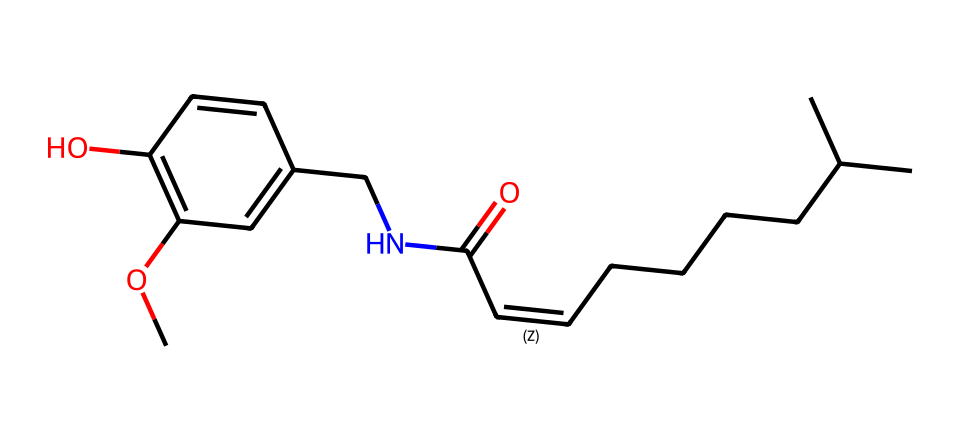What is the molecular formula of capsaicin? To find the molecular formula, we count the number of each type of atom present in the SMILES representation. In this case, we have 18 carbon (C) atoms, 27 hydrogen (H) atoms, 2 nitrogen (N) atoms, and 3 oxygen (O) atoms. Thus, the molecular formula is C18H27N2O3.
Answer: C18H27N2O3 How many rings are present in the chemical structure? By examining the structure, we identify that there are no cyclic components or rings in the SMILES notation. Thus, the total count of rings is zero.
Answer: 0 What type of functional groups are present in capsaicin? From the SMILES representation, we can see there is an amide group (C(=O)N) and hydroxyl group (-OH), which are functional groups commonly associated with organic compounds.
Answer: amide and hydroxyl Which part of the structure contributes to the heat sensation associated with capsaicin? The presence of an amide bond and a long hydrophobic tail in the structure is typically linked to the chemical's ability to interact with TRPV1 receptors in the body, which are responsible for sensing heat and pain.
Answer: amide bond How many oxygen atoms are in the capsaicin molecule? By reviewing the molecular formula derived from the SMILES representation, we can count the oxygen atoms (O). There are three oxygen atoms present.
Answer: 3 What is the longest continuous chain of carbon atoms in capsaicin? In the structure represented by the SMILES, the longest continuous chain of carbon atoms can be traced along the aliphatic portion, which consists of 8 carbon atoms in a continuous linear chain.
Answer: 8 